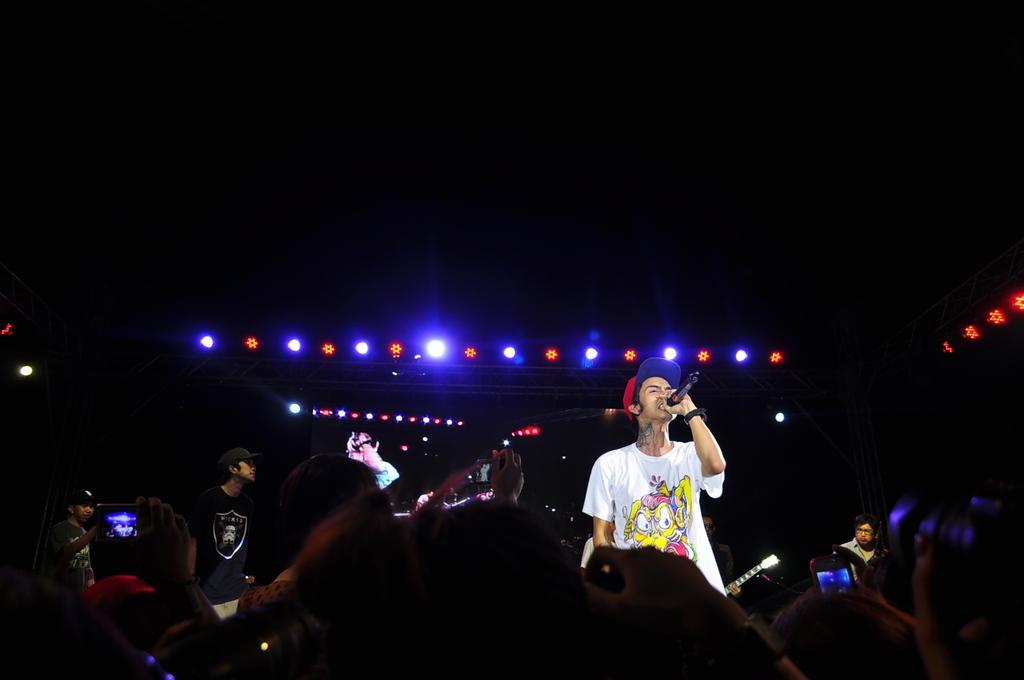Please provide a concise description of this image. In this picture we can see there are groups of people. Some people are holding the objects. There is a man in the white t shirt and he is holding a microphone. Behind the people, there is a screen, lights and the dark background. 